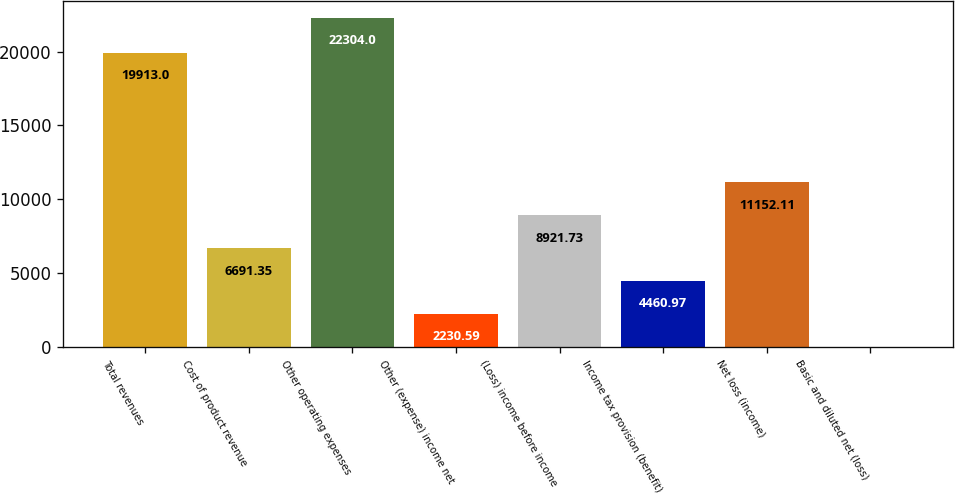Convert chart to OTSL. <chart><loc_0><loc_0><loc_500><loc_500><bar_chart><fcel>Total revenues<fcel>Cost of product revenue<fcel>Other operating expenses<fcel>Other (expense) income net<fcel>(Loss) income before income<fcel>Income tax provision (benefit)<fcel>Net loss (income)<fcel>Basic and diluted net (loss)<nl><fcel>19913<fcel>6691.35<fcel>22304<fcel>2230.59<fcel>8921.73<fcel>4460.97<fcel>11152.1<fcel>0.21<nl></chart> 